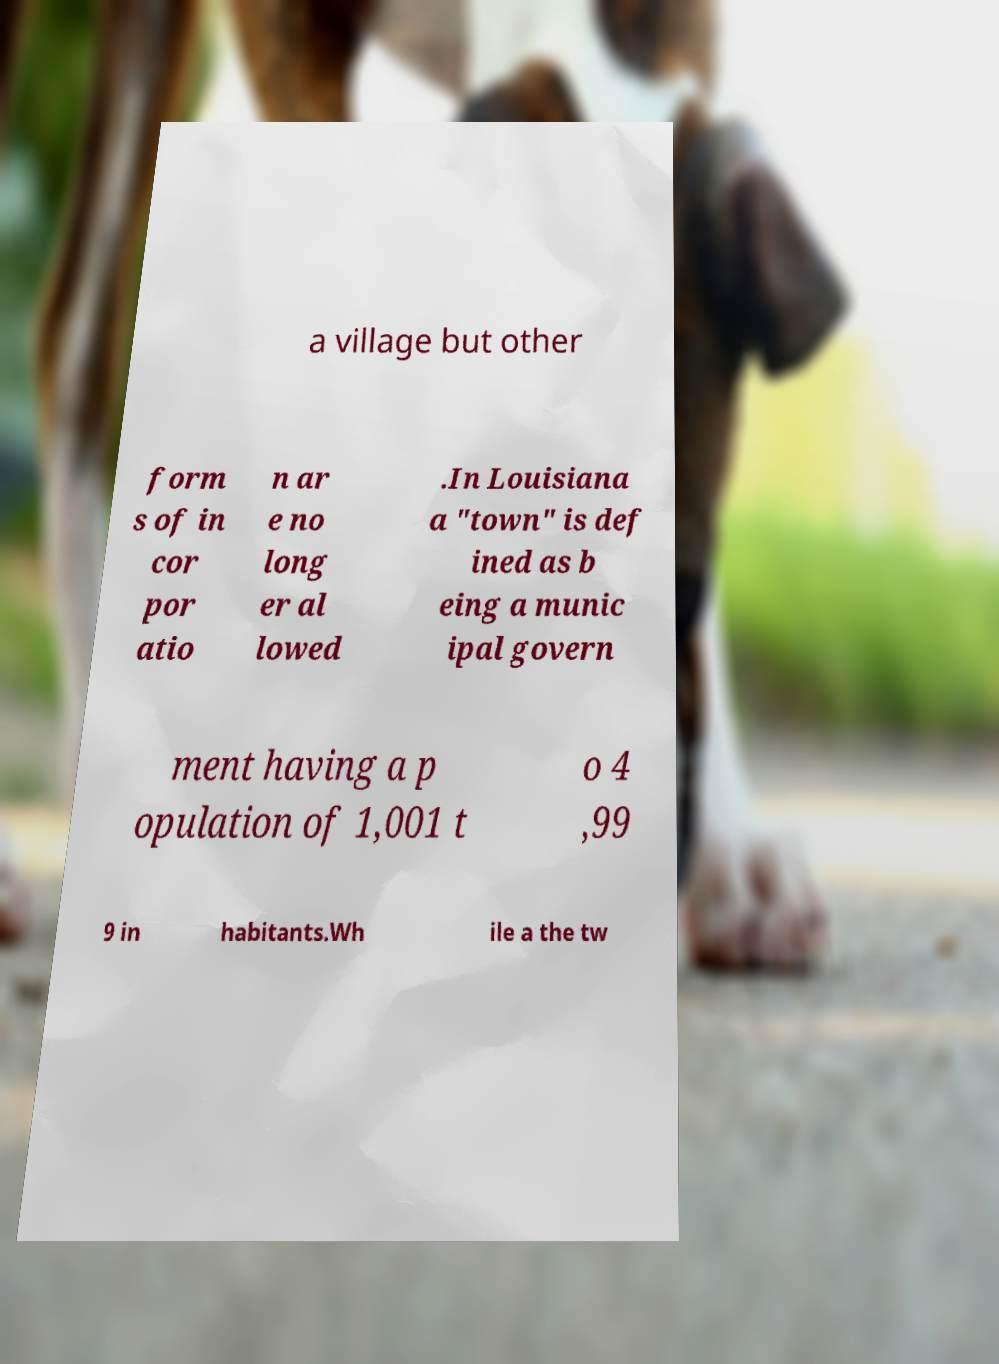Please identify and transcribe the text found in this image. a village but other form s of in cor por atio n ar e no long er al lowed .In Louisiana a "town" is def ined as b eing a munic ipal govern ment having a p opulation of 1,001 t o 4 ,99 9 in habitants.Wh ile a the tw 